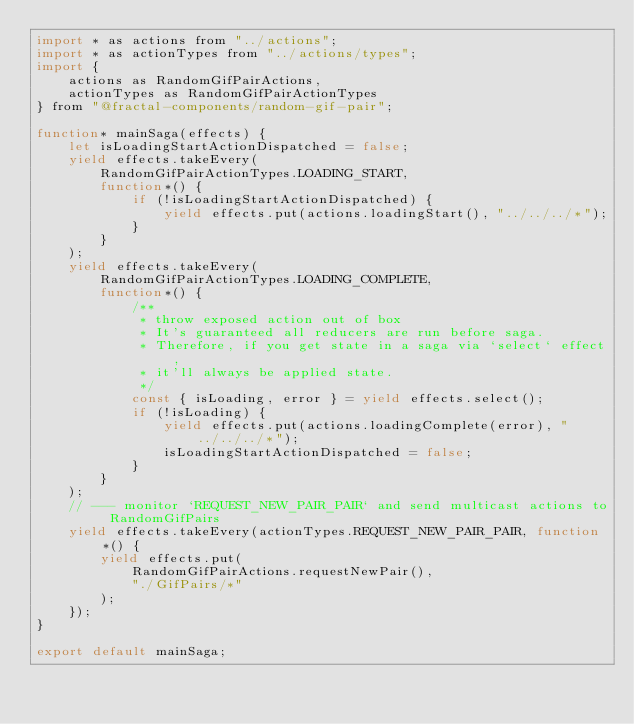<code> <loc_0><loc_0><loc_500><loc_500><_JavaScript_>import * as actions from "../actions";
import * as actionTypes from "../actions/types";
import {
    actions as RandomGifPairActions,
    actionTypes as RandomGifPairActionTypes
} from "@fractal-components/random-gif-pair";

function* mainSaga(effects) {
    let isLoadingStartActionDispatched = false;
    yield effects.takeEvery(
        RandomGifPairActionTypes.LOADING_START,
        function*() {
            if (!isLoadingStartActionDispatched) {
                yield effects.put(actions.loadingStart(), "../../../*");
            }
        }
    );
    yield effects.takeEvery(
        RandomGifPairActionTypes.LOADING_COMPLETE,
        function*() {
            /**
             * throw exposed action out of box
             * It's guaranteed all reducers are run before saga.
             * Therefore, if you get state in a saga via `select` effect,
             * it'll always be applied state.
             */
            const { isLoading, error } = yield effects.select();
            if (!isLoading) {
                yield effects.put(actions.loadingComplete(error), "../../../*");
                isLoadingStartActionDispatched = false;
            }
        }
    );
    // --- monitor `REQUEST_NEW_PAIR_PAIR` and send multicast actions to RandomGifPairs
    yield effects.takeEvery(actionTypes.REQUEST_NEW_PAIR_PAIR, function*() {
        yield effects.put(
            RandomGifPairActions.requestNewPair(),
            "./GifPairs/*"
        );
    });
}

export default mainSaga;
</code> 